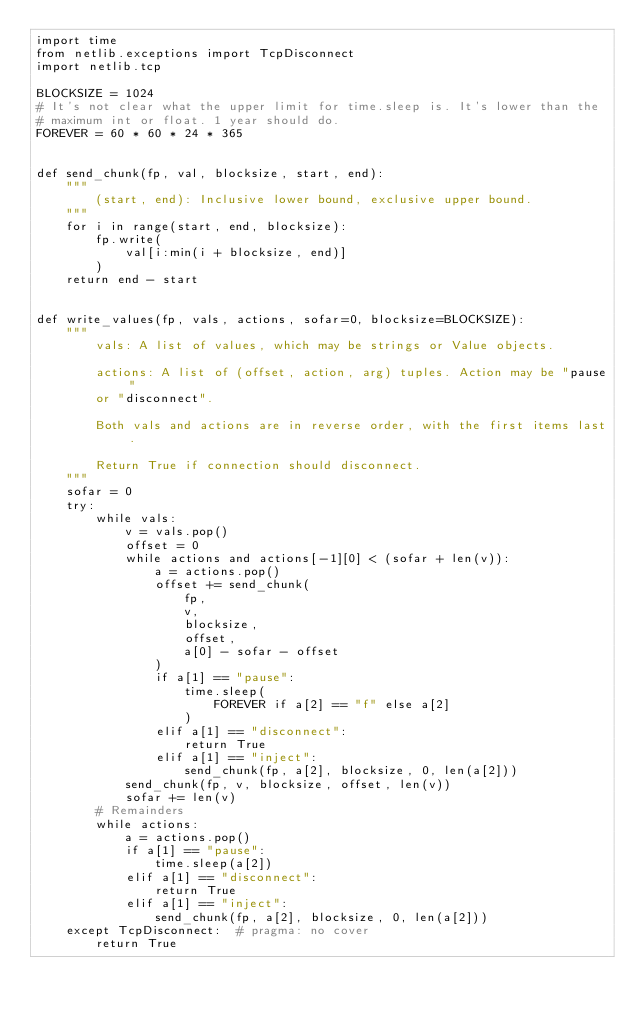Convert code to text. <code><loc_0><loc_0><loc_500><loc_500><_Python_>import time
from netlib.exceptions import TcpDisconnect
import netlib.tcp

BLOCKSIZE = 1024
# It's not clear what the upper limit for time.sleep is. It's lower than the
# maximum int or float. 1 year should do.
FOREVER = 60 * 60 * 24 * 365


def send_chunk(fp, val, blocksize, start, end):
    """
        (start, end): Inclusive lower bound, exclusive upper bound.
    """
    for i in range(start, end, blocksize):
        fp.write(
            val[i:min(i + blocksize, end)]
        )
    return end - start


def write_values(fp, vals, actions, sofar=0, blocksize=BLOCKSIZE):
    """
        vals: A list of values, which may be strings or Value objects.

        actions: A list of (offset, action, arg) tuples. Action may be "pause"
        or "disconnect".

        Both vals and actions are in reverse order, with the first items last.

        Return True if connection should disconnect.
    """
    sofar = 0
    try:
        while vals:
            v = vals.pop()
            offset = 0
            while actions and actions[-1][0] < (sofar + len(v)):
                a = actions.pop()
                offset += send_chunk(
                    fp,
                    v,
                    blocksize,
                    offset,
                    a[0] - sofar - offset
                )
                if a[1] == "pause":
                    time.sleep(
                        FOREVER if a[2] == "f" else a[2]
                    )
                elif a[1] == "disconnect":
                    return True
                elif a[1] == "inject":
                    send_chunk(fp, a[2], blocksize, 0, len(a[2]))
            send_chunk(fp, v, blocksize, offset, len(v))
            sofar += len(v)
        # Remainders
        while actions:
            a = actions.pop()
            if a[1] == "pause":
                time.sleep(a[2])
            elif a[1] == "disconnect":
                return True
            elif a[1] == "inject":
                send_chunk(fp, a[2], blocksize, 0, len(a[2]))
    except TcpDisconnect:  # pragma: no cover
        return True
</code> 